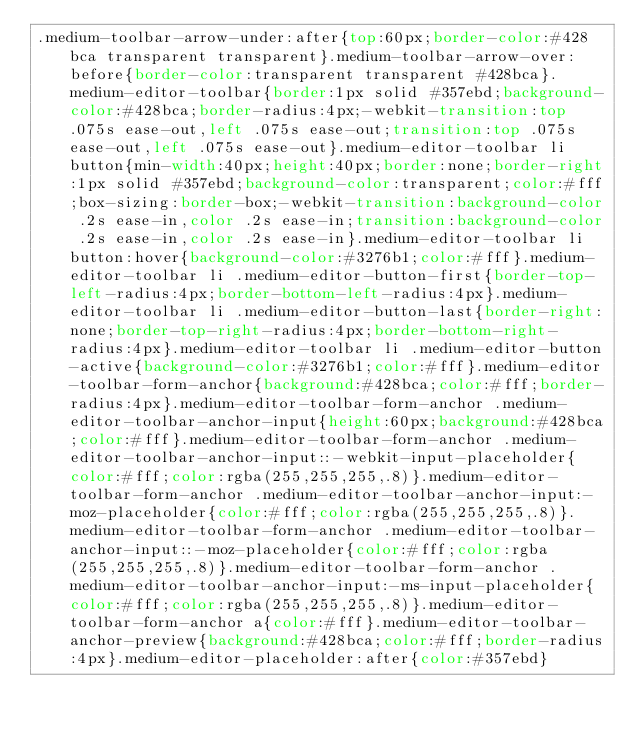<code> <loc_0><loc_0><loc_500><loc_500><_CSS_>.medium-toolbar-arrow-under:after{top:60px;border-color:#428bca transparent transparent}.medium-toolbar-arrow-over:before{border-color:transparent transparent #428bca}.medium-editor-toolbar{border:1px solid #357ebd;background-color:#428bca;border-radius:4px;-webkit-transition:top .075s ease-out,left .075s ease-out;transition:top .075s ease-out,left .075s ease-out}.medium-editor-toolbar li button{min-width:40px;height:40px;border:none;border-right:1px solid #357ebd;background-color:transparent;color:#fff;box-sizing:border-box;-webkit-transition:background-color .2s ease-in,color .2s ease-in;transition:background-color .2s ease-in,color .2s ease-in}.medium-editor-toolbar li button:hover{background-color:#3276b1;color:#fff}.medium-editor-toolbar li .medium-editor-button-first{border-top-left-radius:4px;border-bottom-left-radius:4px}.medium-editor-toolbar li .medium-editor-button-last{border-right:none;border-top-right-radius:4px;border-bottom-right-radius:4px}.medium-editor-toolbar li .medium-editor-button-active{background-color:#3276b1;color:#fff}.medium-editor-toolbar-form-anchor{background:#428bca;color:#fff;border-radius:4px}.medium-editor-toolbar-form-anchor .medium-editor-toolbar-anchor-input{height:60px;background:#428bca;color:#fff}.medium-editor-toolbar-form-anchor .medium-editor-toolbar-anchor-input::-webkit-input-placeholder{color:#fff;color:rgba(255,255,255,.8)}.medium-editor-toolbar-form-anchor .medium-editor-toolbar-anchor-input:-moz-placeholder{color:#fff;color:rgba(255,255,255,.8)}.medium-editor-toolbar-form-anchor .medium-editor-toolbar-anchor-input::-moz-placeholder{color:#fff;color:rgba(255,255,255,.8)}.medium-editor-toolbar-form-anchor .medium-editor-toolbar-anchor-input:-ms-input-placeholder{color:#fff;color:rgba(255,255,255,.8)}.medium-editor-toolbar-form-anchor a{color:#fff}.medium-editor-toolbar-anchor-preview{background:#428bca;color:#fff;border-radius:4px}.medium-editor-placeholder:after{color:#357ebd}</code> 